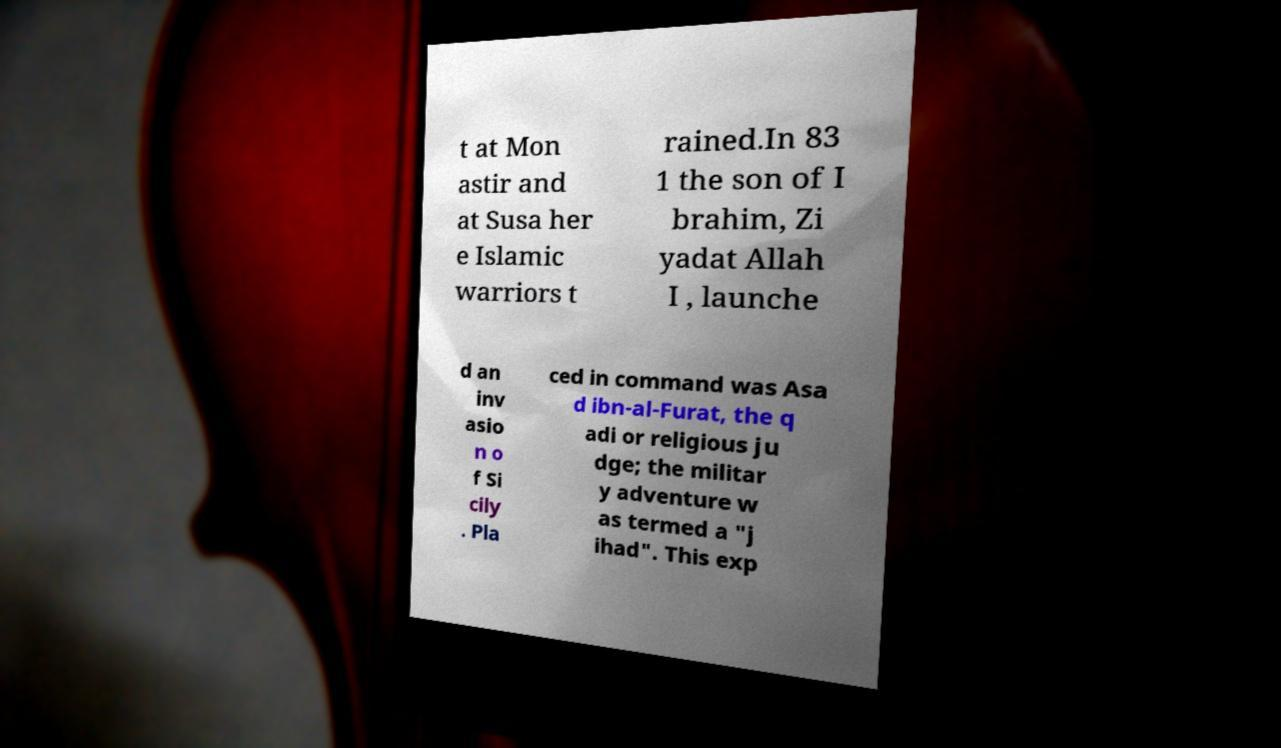Could you assist in decoding the text presented in this image and type it out clearly? t at Mon astir and at Susa her e Islamic warriors t rained.In 83 1 the son of I brahim, Zi yadat Allah I , launche d an inv asio n o f Si cily . Pla ced in command was Asa d ibn-al-Furat, the q adi or religious ju dge; the militar y adventure w as termed a "j ihad". This exp 